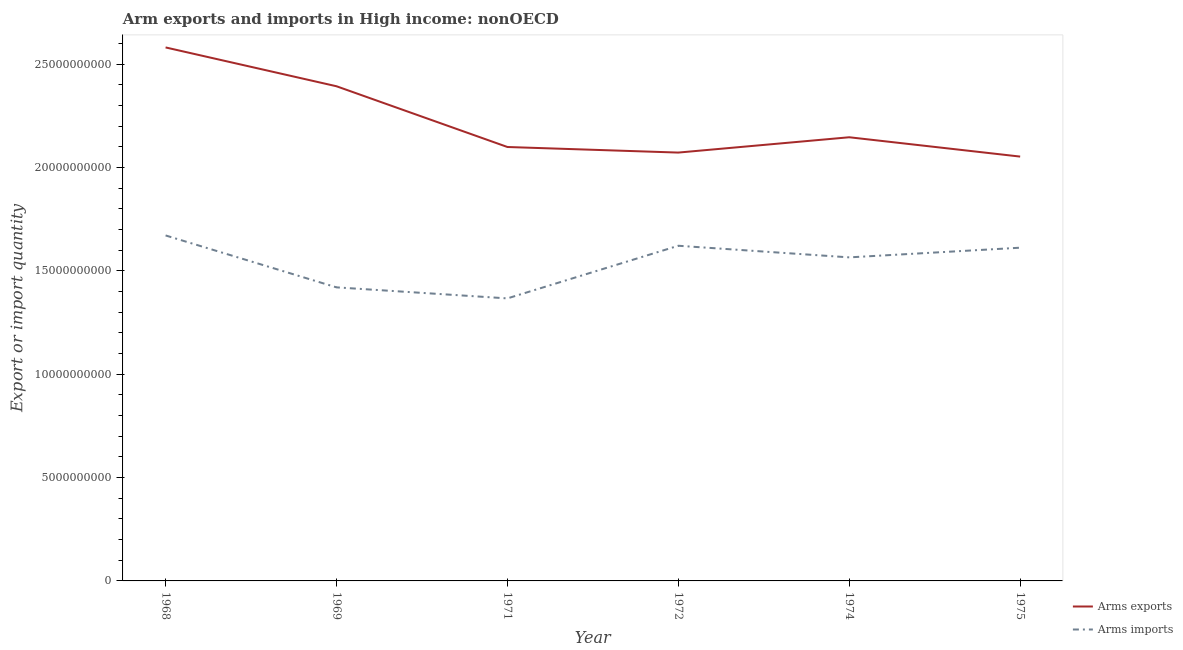Does the line corresponding to arms imports intersect with the line corresponding to arms exports?
Your response must be concise. No. Is the number of lines equal to the number of legend labels?
Your response must be concise. Yes. What is the arms imports in 1969?
Your answer should be compact. 1.42e+1. Across all years, what is the maximum arms exports?
Provide a short and direct response. 2.58e+1. Across all years, what is the minimum arms imports?
Your answer should be compact. 1.37e+1. In which year was the arms imports maximum?
Offer a very short reply. 1968. In which year was the arms exports minimum?
Keep it short and to the point. 1975. What is the total arms imports in the graph?
Offer a terse response. 9.26e+1. What is the difference between the arms exports in 1968 and that in 1974?
Provide a succinct answer. 4.35e+09. What is the difference between the arms imports in 1974 and the arms exports in 1972?
Make the answer very short. -5.07e+09. What is the average arms exports per year?
Your answer should be compact. 2.22e+1. In the year 1974, what is the difference between the arms imports and arms exports?
Your answer should be compact. -5.81e+09. What is the ratio of the arms imports in 1968 to that in 1969?
Make the answer very short. 1.18. Is the arms exports in 1968 less than that in 1971?
Your answer should be compact. No. What is the difference between the highest and the second highest arms exports?
Your answer should be compact. 1.88e+09. What is the difference between the highest and the lowest arms exports?
Give a very brief answer. 5.28e+09. Is the arms exports strictly greater than the arms imports over the years?
Give a very brief answer. Yes. Is the arms exports strictly less than the arms imports over the years?
Provide a short and direct response. No. How many lines are there?
Offer a terse response. 2. Does the graph contain any zero values?
Your answer should be compact. No. Does the graph contain grids?
Keep it short and to the point. No. How are the legend labels stacked?
Ensure brevity in your answer.  Vertical. What is the title of the graph?
Offer a very short reply. Arm exports and imports in High income: nonOECD. Does "Private credit bureau" appear as one of the legend labels in the graph?
Give a very brief answer. No. What is the label or title of the Y-axis?
Make the answer very short. Export or import quantity. What is the Export or import quantity in Arms exports in 1968?
Provide a succinct answer. 2.58e+1. What is the Export or import quantity in Arms imports in 1968?
Offer a terse response. 1.67e+1. What is the Export or import quantity in Arms exports in 1969?
Ensure brevity in your answer.  2.39e+1. What is the Export or import quantity of Arms imports in 1969?
Make the answer very short. 1.42e+1. What is the Export or import quantity in Arms exports in 1971?
Give a very brief answer. 2.10e+1. What is the Export or import quantity of Arms imports in 1971?
Offer a very short reply. 1.37e+1. What is the Export or import quantity of Arms exports in 1972?
Give a very brief answer. 2.07e+1. What is the Export or import quantity in Arms imports in 1972?
Your response must be concise. 1.62e+1. What is the Export or import quantity in Arms exports in 1974?
Offer a very short reply. 2.15e+1. What is the Export or import quantity in Arms imports in 1974?
Your answer should be compact. 1.57e+1. What is the Export or import quantity of Arms exports in 1975?
Provide a succinct answer. 2.05e+1. What is the Export or import quantity in Arms imports in 1975?
Give a very brief answer. 1.61e+1. Across all years, what is the maximum Export or import quantity in Arms exports?
Your answer should be compact. 2.58e+1. Across all years, what is the maximum Export or import quantity in Arms imports?
Offer a very short reply. 1.67e+1. Across all years, what is the minimum Export or import quantity of Arms exports?
Make the answer very short. 2.05e+1. Across all years, what is the minimum Export or import quantity in Arms imports?
Offer a terse response. 1.37e+1. What is the total Export or import quantity in Arms exports in the graph?
Offer a very short reply. 1.33e+11. What is the total Export or import quantity of Arms imports in the graph?
Your answer should be very brief. 9.26e+1. What is the difference between the Export or import quantity of Arms exports in 1968 and that in 1969?
Provide a short and direct response. 1.88e+09. What is the difference between the Export or import quantity in Arms imports in 1968 and that in 1969?
Make the answer very short. 2.51e+09. What is the difference between the Export or import quantity of Arms exports in 1968 and that in 1971?
Your answer should be compact. 4.82e+09. What is the difference between the Export or import quantity of Arms imports in 1968 and that in 1971?
Keep it short and to the point. 3.05e+09. What is the difference between the Export or import quantity of Arms exports in 1968 and that in 1972?
Your answer should be very brief. 5.09e+09. What is the difference between the Export or import quantity in Arms imports in 1968 and that in 1972?
Ensure brevity in your answer.  4.99e+08. What is the difference between the Export or import quantity of Arms exports in 1968 and that in 1974?
Offer a very short reply. 4.35e+09. What is the difference between the Export or import quantity of Arms imports in 1968 and that in 1974?
Your answer should be compact. 1.06e+09. What is the difference between the Export or import quantity of Arms exports in 1968 and that in 1975?
Offer a terse response. 5.28e+09. What is the difference between the Export or import quantity of Arms imports in 1968 and that in 1975?
Offer a very short reply. 5.93e+08. What is the difference between the Export or import quantity of Arms exports in 1969 and that in 1971?
Give a very brief answer. 2.94e+09. What is the difference between the Export or import quantity in Arms imports in 1969 and that in 1971?
Your answer should be compact. 5.34e+08. What is the difference between the Export or import quantity of Arms exports in 1969 and that in 1972?
Give a very brief answer. 3.21e+09. What is the difference between the Export or import quantity of Arms imports in 1969 and that in 1972?
Offer a very short reply. -2.01e+09. What is the difference between the Export or import quantity in Arms exports in 1969 and that in 1974?
Keep it short and to the point. 2.47e+09. What is the difference between the Export or import quantity in Arms imports in 1969 and that in 1974?
Your response must be concise. -1.45e+09. What is the difference between the Export or import quantity of Arms exports in 1969 and that in 1975?
Your answer should be very brief. 3.40e+09. What is the difference between the Export or import quantity of Arms imports in 1969 and that in 1975?
Your response must be concise. -1.92e+09. What is the difference between the Export or import quantity in Arms exports in 1971 and that in 1972?
Your answer should be compact. 2.70e+08. What is the difference between the Export or import quantity of Arms imports in 1971 and that in 1972?
Provide a short and direct response. -2.55e+09. What is the difference between the Export or import quantity in Arms exports in 1971 and that in 1974?
Your answer should be compact. -4.71e+08. What is the difference between the Export or import quantity in Arms imports in 1971 and that in 1974?
Make the answer very short. -1.98e+09. What is the difference between the Export or import quantity of Arms exports in 1971 and that in 1975?
Give a very brief answer. 4.64e+08. What is the difference between the Export or import quantity in Arms imports in 1971 and that in 1975?
Make the answer very short. -2.45e+09. What is the difference between the Export or import quantity of Arms exports in 1972 and that in 1974?
Offer a very short reply. -7.41e+08. What is the difference between the Export or import quantity of Arms imports in 1972 and that in 1974?
Keep it short and to the point. 5.62e+08. What is the difference between the Export or import quantity of Arms exports in 1972 and that in 1975?
Give a very brief answer. 1.94e+08. What is the difference between the Export or import quantity in Arms imports in 1972 and that in 1975?
Offer a terse response. 9.40e+07. What is the difference between the Export or import quantity of Arms exports in 1974 and that in 1975?
Keep it short and to the point. 9.35e+08. What is the difference between the Export or import quantity in Arms imports in 1974 and that in 1975?
Give a very brief answer. -4.68e+08. What is the difference between the Export or import quantity of Arms exports in 1968 and the Export or import quantity of Arms imports in 1969?
Give a very brief answer. 1.16e+1. What is the difference between the Export or import quantity of Arms exports in 1968 and the Export or import quantity of Arms imports in 1971?
Offer a very short reply. 1.21e+1. What is the difference between the Export or import quantity in Arms exports in 1968 and the Export or import quantity in Arms imports in 1972?
Give a very brief answer. 9.60e+09. What is the difference between the Export or import quantity in Arms exports in 1968 and the Export or import quantity in Arms imports in 1974?
Your answer should be compact. 1.02e+1. What is the difference between the Export or import quantity in Arms exports in 1968 and the Export or import quantity in Arms imports in 1975?
Ensure brevity in your answer.  9.69e+09. What is the difference between the Export or import quantity of Arms exports in 1969 and the Export or import quantity of Arms imports in 1971?
Offer a terse response. 1.03e+1. What is the difference between the Export or import quantity of Arms exports in 1969 and the Export or import quantity of Arms imports in 1972?
Your response must be concise. 7.72e+09. What is the difference between the Export or import quantity in Arms exports in 1969 and the Export or import quantity in Arms imports in 1974?
Provide a short and direct response. 8.28e+09. What is the difference between the Export or import quantity in Arms exports in 1969 and the Export or import quantity in Arms imports in 1975?
Provide a succinct answer. 7.81e+09. What is the difference between the Export or import quantity in Arms exports in 1971 and the Export or import quantity in Arms imports in 1972?
Offer a very short reply. 4.78e+09. What is the difference between the Export or import quantity in Arms exports in 1971 and the Export or import quantity in Arms imports in 1974?
Offer a terse response. 5.34e+09. What is the difference between the Export or import quantity in Arms exports in 1971 and the Export or import quantity in Arms imports in 1975?
Provide a short and direct response. 4.87e+09. What is the difference between the Export or import quantity of Arms exports in 1972 and the Export or import quantity of Arms imports in 1974?
Your answer should be compact. 5.07e+09. What is the difference between the Export or import quantity in Arms exports in 1972 and the Export or import quantity in Arms imports in 1975?
Provide a succinct answer. 4.60e+09. What is the difference between the Export or import quantity in Arms exports in 1974 and the Export or import quantity in Arms imports in 1975?
Offer a very short reply. 5.34e+09. What is the average Export or import quantity of Arms exports per year?
Offer a very short reply. 2.22e+1. What is the average Export or import quantity of Arms imports per year?
Offer a very short reply. 1.54e+1. In the year 1968, what is the difference between the Export or import quantity in Arms exports and Export or import quantity in Arms imports?
Make the answer very short. 9.10e+09. In the year 1969, what is the difference between the Export or import quantity in Arms exports and Export or import quantity in Arms imports?
Make the answer very short. 9.73e+09. In the year 1971, what is the difference between the Export or import quantity of Arms exports and Export or import quantity of Arms imports?
Provide a short and direct response. 7.33e+09. In the year 1972, what is the difference between the Export or import quantity in Arms exports and Export or import quantity in Arms imports?
Keep it short and to the point. 4.51e+09. In the year 1974, what is the difference between the Export or import quantity in Arms exports and Export or import quantity in Arms imports?
Provide a short and direct response. 5.81e+09. In the year 1975, what is the difference between the Export or import quantity of Arms exports and Export or import quantity of Arms imports?
Make the answer very short. 4.41e+09. What is the ratio of the Export or import quantity in Arms exports in 1968 to that in 1969?
Your answer should be very brief. 1.08. What is the ratio of the Export or import quantity in Arms imports in 1968 to that in 1969?
Your answer should be compact. 1.18. What is the ratio of the Export or import quantity of Arms exports in 1968 to that in 1971?
Offer a terse response. 1.23. What is the ratio of the Export or import quantity of Arms imports in 1968 to that in 1971?
Your response must be concise. 1.22. What is the ratio of the Export or import quantity of Arms exports in 1968 to that in 1972?
Keep it short and to the point. 1.25. What is the ratio of the Export or import quantity of Arms imports in 1968 to that in 1972?
Offer a very short reply. 1.03. What is the ratio of the Export or import quantity of Arms exports in 1968 to that in 1974?
Your answer should be compact. 1.2. What is the ratio of the Export or import quantity of Arms imports in 1968 to that in 1974?
Your answer should be very brief. 1.07. What is the ratio of the Export or import quantity of Arms exports in 1968 to that in 1975?
Your answer should be compact. 1.26. What is the ratio of the Export or import quantity in Arms imports in 1968 to that in 1975?
Make the answer very short. 1.04. What is the ratio of the Export or import quantity in Arms exports in 1969 to that in 1971?
Your answer should be very brief. 1.14. What is the ratio of the Export or import quantity of Arms imports in 1969 to that in 1971?
Give a very brief answer. 1.04. What is the ratio of the Export or import quantity of Arms exports in 1969 to that in 1972?
Your answer should be compact. 1.15. What is the ratio of the Export or import quantity of Arms imports in 1969 to that in 1972?
Keep it short and to the point. 0.88. What is the ratio of the Export or import quantity of Arms exports in 1969 to that in 1974?
Give a very brief answer. 1.11. What is the ratio of the Export or import quantity in Arms imports in 1969 to that in 1974?
Your answer should be very brief. 0.91. What is the ratio of the Export or import quantity of Arms exports in 1969 to that in 1975?
Offer a very short reply. 1.17. What is the ratio of the Export or import quantity in Arms imports in 1969 to that in 1975?
Give a very brief answer. 0.88. What is the ratio of the Export or import quantity of Arms exports in 1971 to that in 1972?
Make the answer very short. 1.01. What is the ratio of the Export or import quantity of Arms imports in 1971 to that in 1972?
Keep it short and to the point. 0.84. What is the ratio of the Export or import quantity of Arms exports in 1971 to that in 1974?
Offer a very short reply. 0.98. What is the ratio of the Export or import quantity in Arms imports in 1971 to that in 1974?
Make the answer very short. 0.87. What is the ratio of the Export or import quantity in Arms exports in 1971 to that in 1975?
Your answer should be compact. 1.02. What is the ratio of the Export or import quantity of Arms imports in 1971 to that in 1975?
Give a very brief answer. 0.85. What is the ratio of the Export or import quantity in Arms exports in 1972 to that in 1974?
Keep it short and to the point. 0.97. What is the ratio of the Export or import quantity of Arms imports in 1972 to that in 1974?
Provide a short and direct response. 1.04. What is the ratio of the Export or import quantity of Arms exports in 1972 to that in 1975?
Offer a terse response. 1.01. What is the ratio of the Export or import quantity in Arms exports in 1974 to that in 1975?
Provide a short and direct response. 1.05. What is the difference between the highest and the second highest Export or import quantity of Arms exports?
Give a very brief answer. 1.88e+09. What is the difference between the highest and the second highest Export or import quantity of Arms imports?
Your answer should be very brief. 4.99e+08. What is the difference between the highest and the lowest Export or import quantity in Arms exports?
Keep it short and to the point. 5.28e+09. What is the difference between the highest and the lowest Export or import quantity of Arms imports?
Provide a succinct answer. 3.05e+09. 